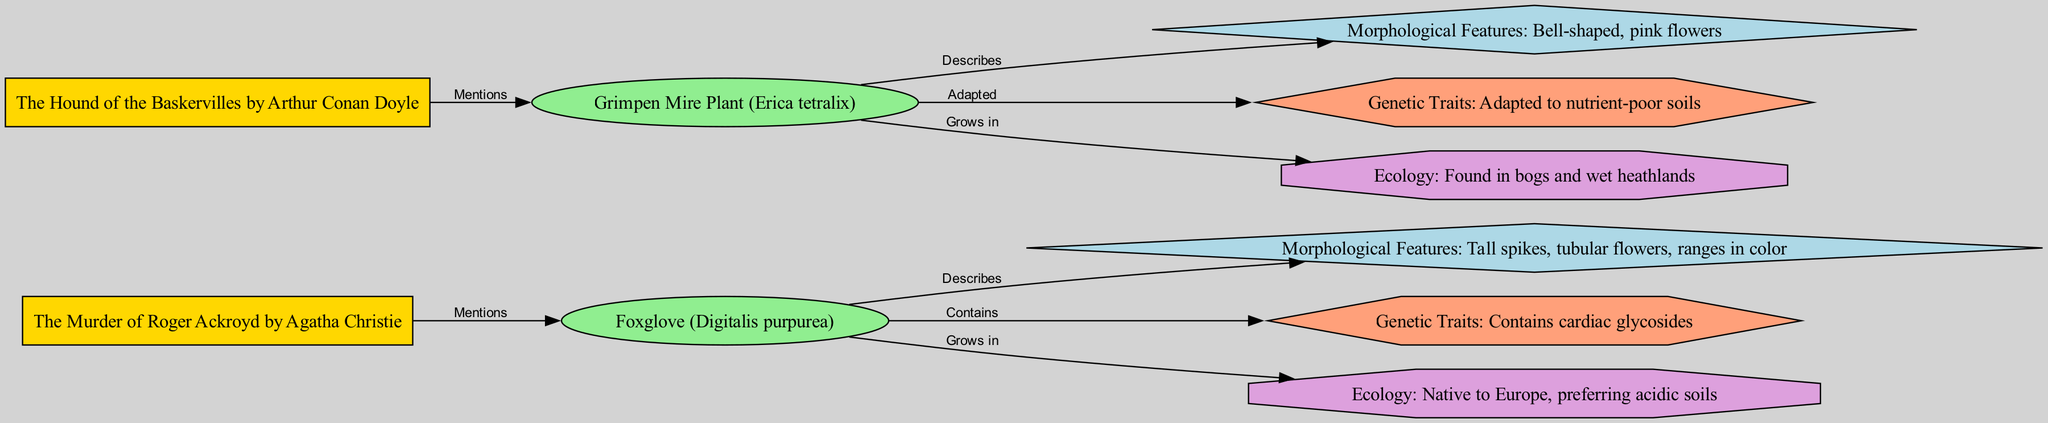What book mentions Foxglove? The connection in the diagram shows that "The Murder of Roger Ackroyd by Agatha Christie" has an edge labeled "Mentions" that directly links to the "Foxglove" node.
Answer: The Murder of Roger Ackroyd by Agatha Christie What is the genetic trait associated with Foxglove? The diagram indicates that the "Foxglove" node has an edge labeled "Contains" leading to "Genetic Traits: Contains cardiac glycosides," thus pointing out its genetic characteristic.
Answer: Contains cardiac glycosides How many plants are referenced in the diagram? By counting the nodes marked as "plant," which are "Foxglove" and "Grimpen Mire Plant," we determine there are two plants mentioned in total.
Answer: 2 What morphological feature distinguishes the Grimpen Mire Plant? The direct connection from the "Grimpen Mire Plant" node to the "Morphological Features" node shows that it has "Bell-shaped, pink flowers," providing the specific distinguishing feature.
Answer: Bell-shaped, pink flowers Which plant is adapted to nutrient-poor soils? The "Grimpen Mire Plant" has an edge labeled "Adapted" that leads to the node specifying its genetic trait of being "Adapted to nutrient-poor soils." Thus, it is the plant that exhibits this adaptation.
Answer: Grimpen Mire Plant What ecological condition is preferred by Foxglove? Following the edge from "Foxglove" labeled "Grows in," we see that the connected node states "Ecology: Native to Europe, preferring acidic soils," indicating its ecological preference.
Answer: Preferring acidic soils Which novel includes the Grimpen Mire Plant? The diagram shows an edge labeled "Mentions" from "The Hound of the Baskervilles by Arthur Conan Doyle" to "Grimpen Mire Plant," confirming that the plant is referenced in this book.
Answer: The Hound of the Baskervilles by Arthur Conan Doyle What type of plant is Foxglove? The "Foxglove" node is classified as a "plant," connecting it to the broader category represented on the diagram.
Answer: Plant What are the morphological features of Foxglove? The edge from "Foxglove" leading to "Morphological Features: Tall spikes, tubular flowers, ranges in color" provides the specific morphological characteristics associated with this plant.
Answer: Tall spikes, tubular flowers, ranges in color 